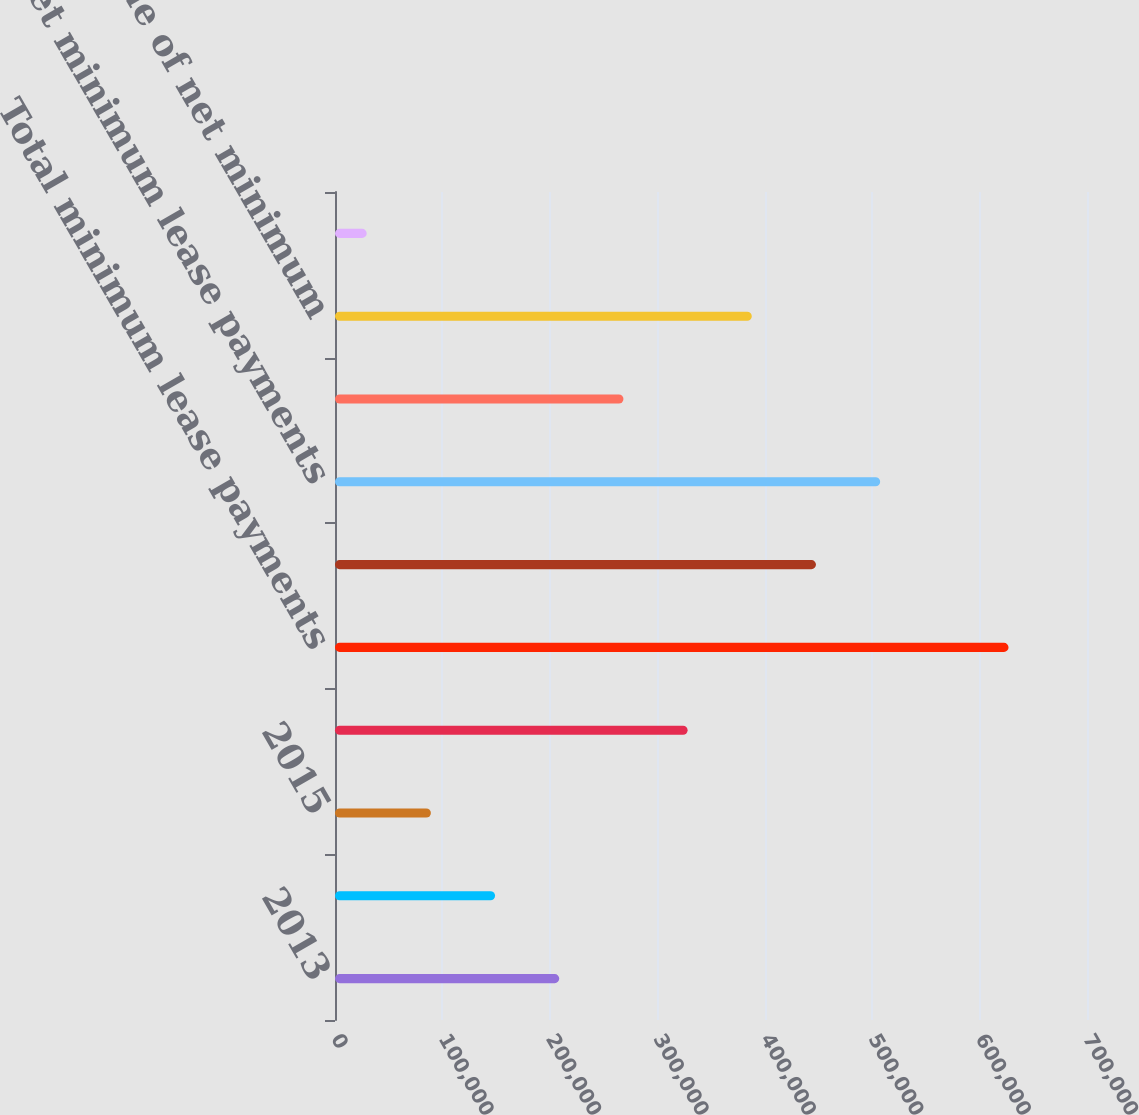Convert chart. <chart><loc_0><loc_0><loc_500><loc_500><bar_chart><fcel>2013<fcel>2014<fcel>2015<fcel>Thereafter<fcel>Total minimum lease payments<fcel>Less Amount representing lease<fcel>Net minimum lease payments<fcel>Less Amount representing<fcel>Present value of net minimum<fcel>Long-term portion of capital<nl><fcel>208746<fcel>149002<fcel>89258.7<fcel>328234<fcel>626952<fcel>447721<fcel>507465<fcel>268490<fcel>387977<fcel>29515<nl></chart> 